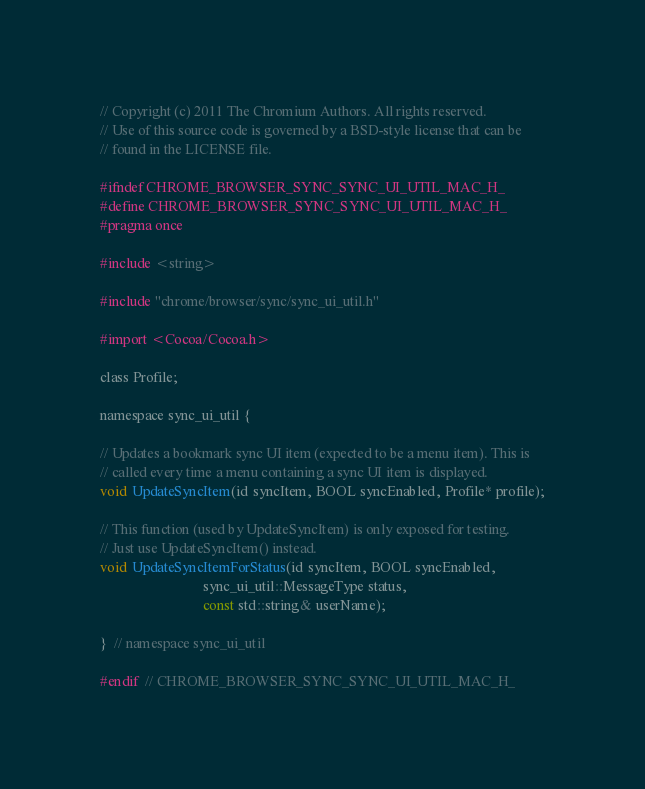<code> <loc_0><loc_0><loc_500><loc_500><_C_>// Copyright (c) 2011 The Chromium Authors. All rights reserved.
// Use of this source code is governed by a BSD-style license that can be
// found in the LICENSE file.

#ifndef CHROME_BROWSER_SYNC_SYNC_UI_UTIL_MAC_H_
#define CHROME_BROWSER_SYNC_SYNC_UI_UTIL_MAC_H_
#pragma once

#include <string>

#include "chrome/browser/sync/sync_ui_util.h"

#import <Cocoa/Cocoa.h>

class Profile;

namespace sync_ui_util {

// Updates a bookmark sync UI item (expected to be a menu item). This is
// called every time a menu containing a sync UI item is displayed.
void UpdateSyncItem(id syncItem, BOOL syncEnabled, Profile* profile);

// This function (used by UpdateSyncItem) is only exposed for testing.
// Just use UpdateSyncItem() instead.
void UpdateSyncItemForStatus(id syncItem, BOOL syncEnabled,
                             sync_ui_util::MessageType status,
                             const std::string& userName);

}  // namespace sync_ui_util

#endif  // CHROME_BROWSER_SYNC_SYNC_UI_UTIL_MAC_H_

</code> 